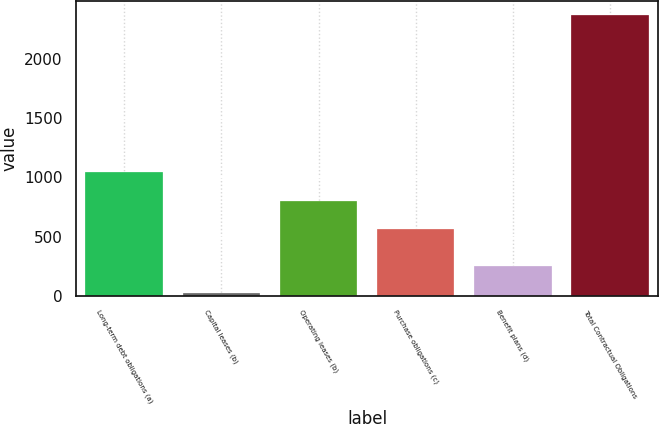<chart> <loc_0><loc_0><loc_500><loc_500><bar_chart><fcel>Long-term debt obligations (a)<fcel>Capital leases (b)<fcel>Operating leases (b)<fcel>Purchase obligations (c)<fcel>Benefit plans (d)<fcel>Total Contractual Obligations<nl><fcel>1048<fcel>20<fcel>802.9<fcel>568<fcel>254.9<fcel>2369<nl></chart> 